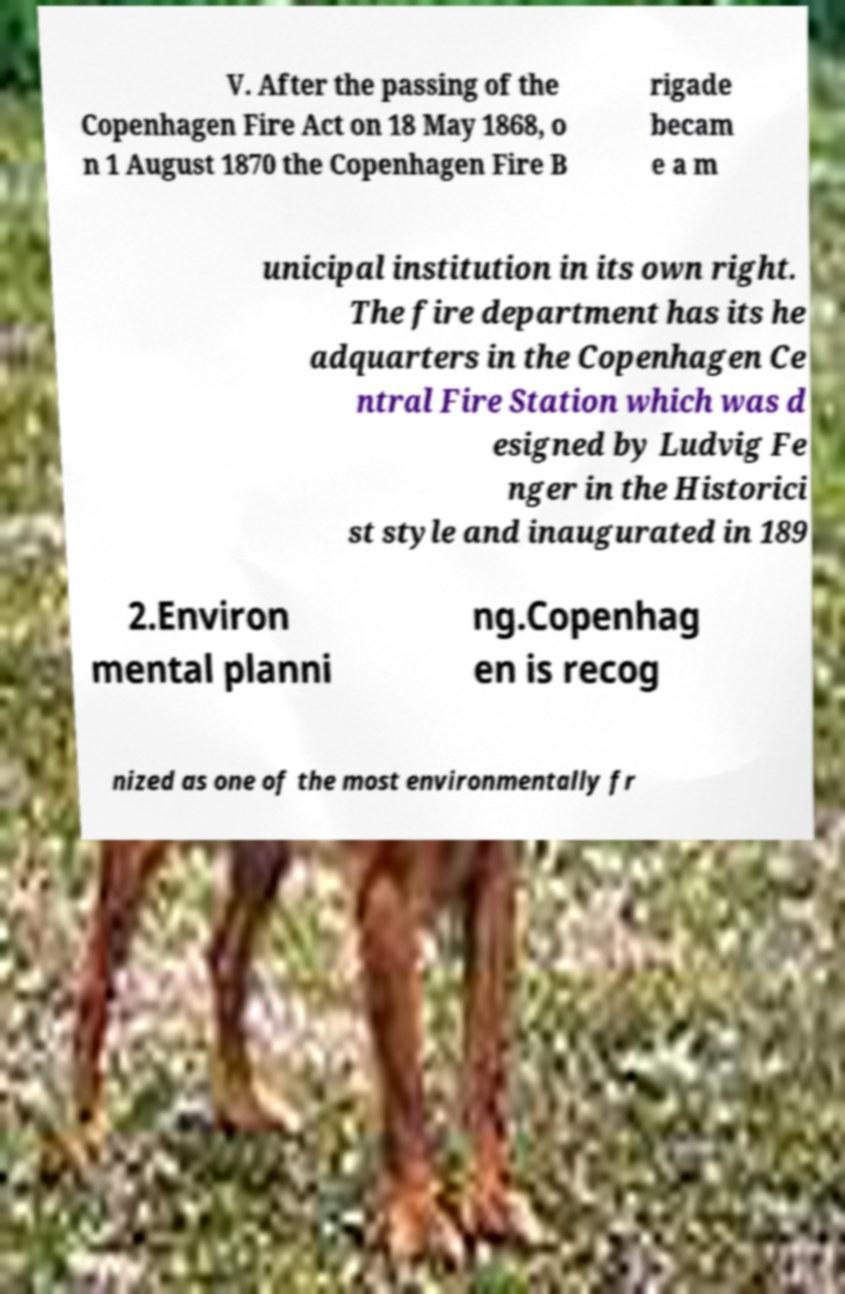Could you assist in decoding the text presented in this image and type it out clearly? V. After the passing of the Copenhagen Fire Act on 18 May 1868, o n 1 August 1870 the Copenhagen Fire B rigade becam e a m unicipal institution in its own right. The fire department has its he adquarters in the Copenhagen Ce ntral Fire Station which was d esigned by Ludvig Fe nger in the Historici st style and inaugurated in 189 2.Environ mental planni ng.Copenhag en is recog nized as one of the most environmentally fr 